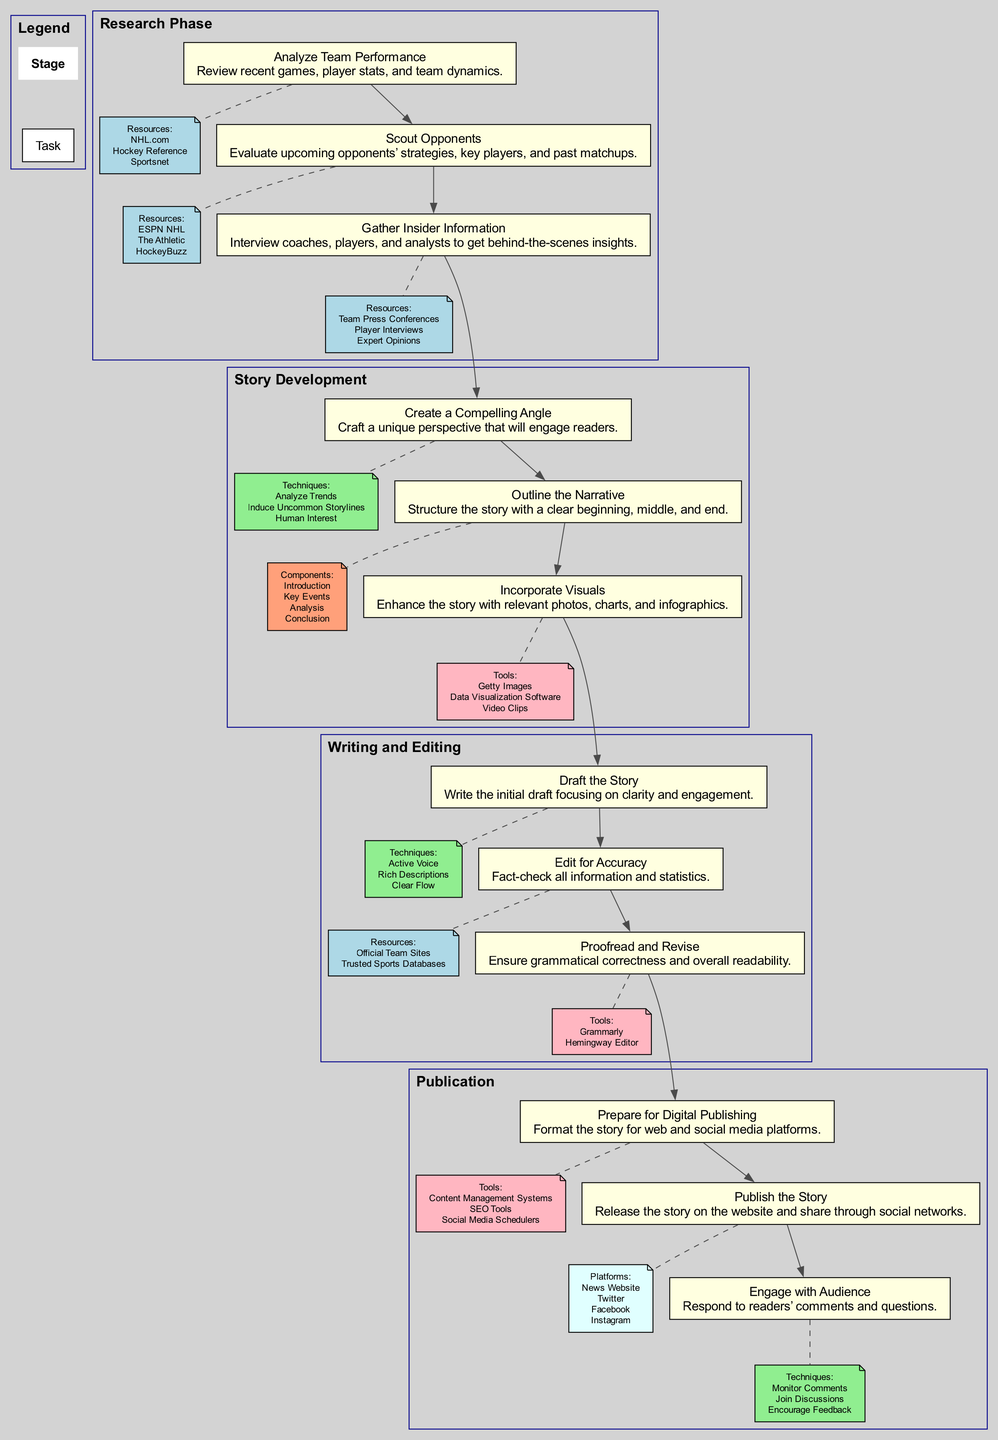What is the first task in the Research Phase? The first task listed under the Research Phase is "Analyze Team Performance". The diagram arranges tasks within each stage, and since "Analyze Team Performance" is the first entry in the tasks for the Research Phase, it is the correct answer.
Answer: Analyze Team Performance How many tasks are there in the Story Development stage? Upon examining the Story Development stage in the diagram, there are three tasks: "Create a Compelling Angle", "Outline the Narrative", and "Incorporate Visuals". Consequently, by counting these entries, the answer can be determined.
Answer: 3 What follows the "Gather Insider Information" task? The diagram shows that "Gather Insider Information" is the last task of the Research Phase. The next stage after the Research Phase is the Story Development stage, which begins with "Create a Compelling Angle". Therefore, by following the flow of tasks, we see what comes next.
Answer: Create a Compelling Angle Which stage includes the task "Proofread and Revise"? Analyzing the sequence of stages listed in the diagram, "Proofread and Revise" is located in the Writing and Editing stage. This task is captured under that stage, therefore it forms the basis for the answer.
Answer: Writing and Editing What resource is mentioned for the task "Edit for Accuracy"? The task "Edit for Accuracy" specifically mentions resources for this process, which are "Official Team Sites" and "Trusted Sports Databases". Since these resources are explicitly listed in the flow chart, they can be easily identified accordingly.
Answer: Official Team Sites, Trusted Sports Databases Which task is positioned as the end of the Publication stage? The last task in the Publication stage is "Engage with Audience". By looking at the organization of tasks within that stage in the diagram, we can accurately establish that this task concludes the Publication phase.
Answer: Engage with Audience What are two techniques suggested for creating a compelling angle? For the task "Create a Compelling Angle", the techniques listed are "Analyze Trends" and "Induce Uncommon Storylines". These details are shown in the flow chart associated with this specific task, hence they can be directly cited as the answer.
Answer: Analyze Trends, Induce Uncommon Storylines How are the Writing and Editing stage tasks connected to the Story Development tasks? The tasks of the Writing and Editing stage are connected to the tasks of the Story Development stage through a directed edge, signifying the flow from the end of Story Development to the beginning of Writing and Editing. Thus, examining the diagram for these connections confirms the answer.
Answer: Through directed edge connections Which tools are recommended for the task "Prepare for Digital Publishing"? The task "Prepare for Digital Publishing" lists several tools, such as "Content Management Systems", "SEO Tools", and "Social Media Schedulers", as resources. These tools are clearly outlined under this task in the flow chart, making them easily identifiable.
Answer: Content Management Systems, SEO Tools, Social Media Schedulers 